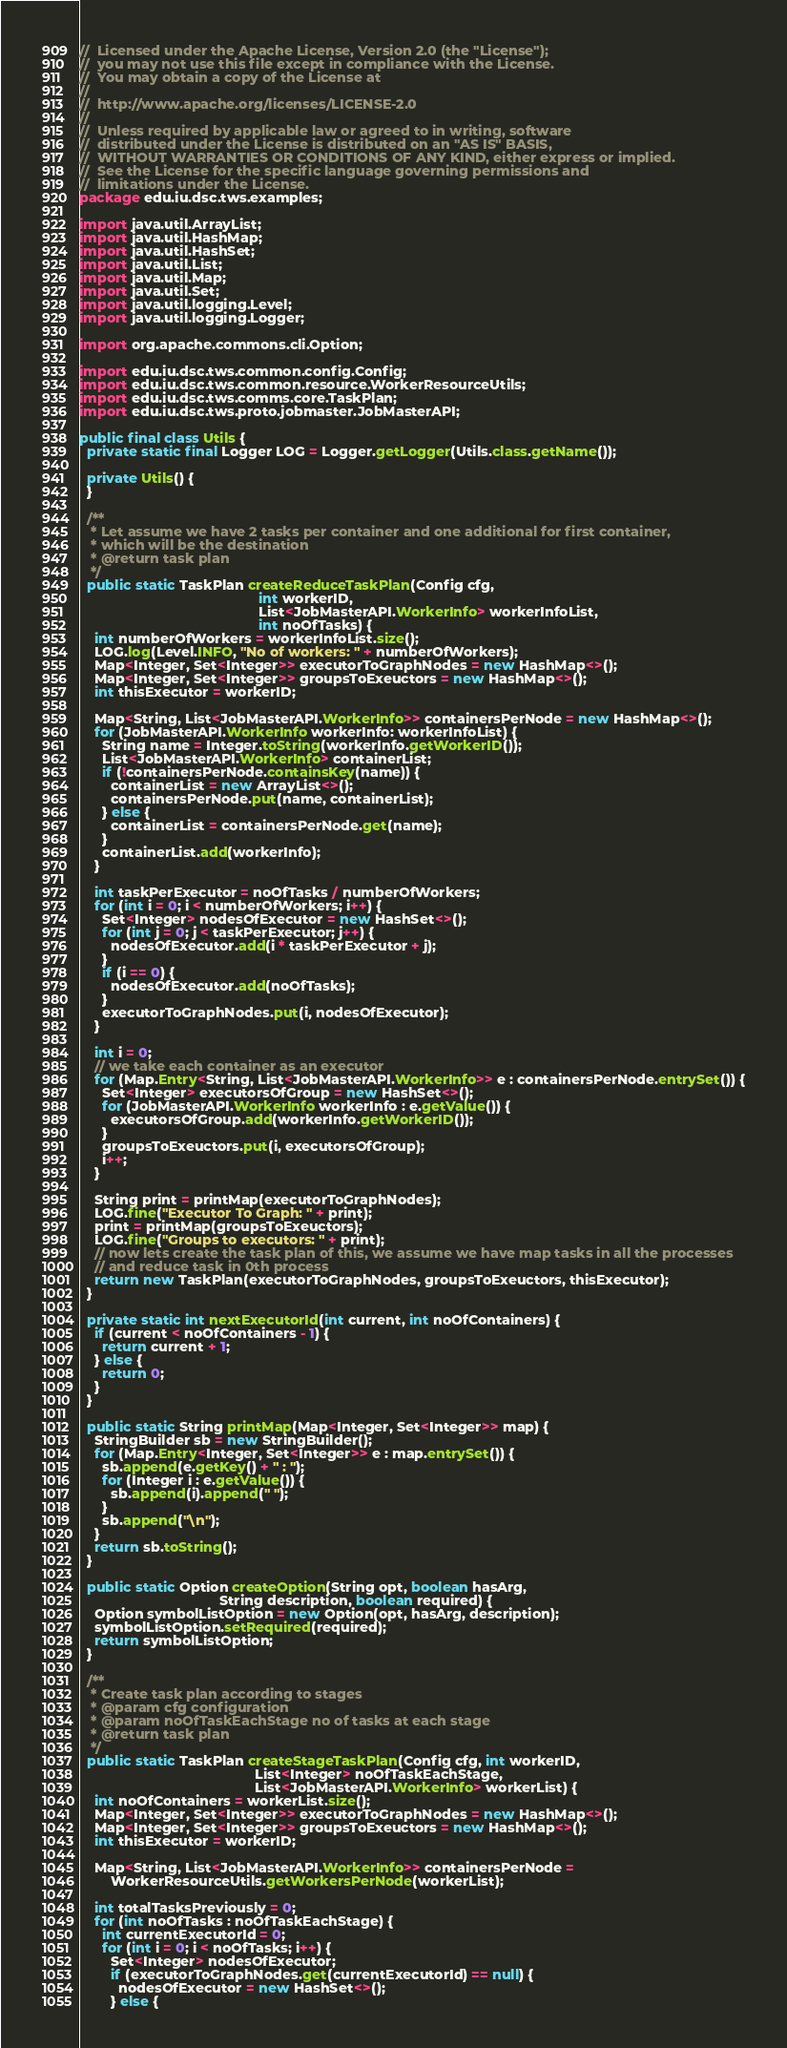<code> <loc_0><loc_0><loc_500><loc_500><_Java_>//  Licensed under the Apache License, Version 2.0 (the "License");
//  you may not use this file except in compliance with the License.
//  You may obtain a copy of the License at
//
//  http://www.apache.org/licenses/LICENSE-2.0
//
//  Unless required by applicable law or agreed to in writing, software
//  distributed under the License is distributed on an "AS IS" BASIS,
//  WITHOUT WARRANTIES OR CONDITIONS OF ANY KIND, either express or implied.
//  See the License for the specific language governing permissions and
//  limitations under the License.
package edu.iu.dsc.tws.examples;

import java.util.ArrayList;
import java.util.HashMap;
import java.util.HashSet;
import java.util.List;
import java.util.Map;
import java.util.Set;
import java.util.logging.Level;
import java.util.logging.Logger;

import org.apache.commons.cli.Option;

import edu.iu.dsc.tws.common.config.Config;
import edu.iu.dsc.tws.common.resource.WorkerResourceUtils;
import edu.iu.dsc.tws.comms.core.TaskPlan;
import edu.iu.dsc.tws.proto.jobmaster.JobMasterAPI;

public final class Utils {
  private static final Logger LOG = Logger.getLogger(Utils.class.getName());

  private Utils() {
  }

  /**
   * Let assume we have 2 tasks per container and one additional for first container,
   * which will be the destination
   * @return task plan
   */
  public static TaskPlan createReduceTaskPlan(Config cfg,
                                              int workerID,
                                              List<JobMasterAPI.WorkerInfo> workerInfoList,
                                              int noOfTasks) {
    int numberOfWorkers = workerInfoList.size();
    LOG.log(Level.INFO, "No of workers: " + numberOfWorkers);
    Map<Integer, Set<Integer>> executorToGraphNodes = new HashMap<>();
    Map<Integer, Set<Integer>> groupsToExeuctors = new HashMap<>();
    int thisExecutor = workerID;

    Map<String, List<JobMasterAPI.WorkerInfo>> containersPerNode = new HashMap<>();
    for (JobMasterAPI.WorkerInfo workerInfo: workerInfoList) {
      String name = Integer.toString(workerInfo.getWorkerID());
      List<JobMasterAPI.WorkerInfo> containerList;
      if (!containersPerNode.containsKey(name)) {
        containerList = new ArrayList<>();
        containersPerNode.put(name, containerList);
      } else {
        containerList = containersPerNode.get(name);
      }
      containerList.add(workerInfo);
    }

    int taskPerExecutor = noOfTasks / numberOfWorkers;
    for (int i = 0; i < numberOfWorkers; i++) {
      Set<Integer> nodesOfExecutor = new HashSet<>();
      for (int j = 0; j < taskPerExecutor; j++) {
        nodesOfExecutor.add(i * taskPerExecutor + j);
      }
      if (i == 0) {
        nodesOfExecutor.add(noOfTasks);
      }
      executorToGraphNodes.put(i, nodesOfExecutor);
    }

    int i = 0;
    // we take each container as an executor
    for (Map.Entry<String, List<JobMasterAPI.WorkerInfo>> e : containersPerNode.entrySet()) {
      Set<Integer> executorsOfGroup = new HashSet<>();
      for (JobMasterAPI.WorkerInfo workerInfo : e.getValue()) {
        executorsOfGroup.add(workerInfo.getWorkerID());
      }
      groupsToExeuctors.put(i, executorsOfGroup);
      i++;
    }

    String print = printMap(executorToGraphNodes);
    LOG.fine("Executor To Graph: " + print);
    print = printMap(groupsToExeuctors);
    LOG.fine("Groups to executors: " + print);
    // now lets create the task plan of this, we assume we have map tasks in all the processes
    // and reduce task in 0th process
    return new TaskPlan(executorToGraphNodes, groupsToExeuctors, thisExecutor);
  }

  private static int nextExecutorId(int current, int noOfContainers) {
    if (current < noOfContainers - 1) {
      return current + 1;
    } else {
      return 0;
    }
  }

  public static String printMap(Map<Integer, Set<Integer>> map) {
    StringBuilder sb = new StringBuilder();
    for (Map.Entry<Integer, Set<Integer>> e : map.entrySet()) {
      sb.append(e.getKey() + " : ");
      for (Integer i : e.getValue()) {
        sb.append(i).append(" ");
      }
      sb.append("\n");
    }
    return sb.toString();
  }

  public static Option createOption(String opt, boolean hasArg,
                                    String description, boolean required) {
    Option symbolListOption = new Option(opt, hasArg, description);
    symbolListOption.setRequired(required);
    return symbolListOption;
  }

  /**
   * Create task plan according to stages
   * @param cfg configuration
   * @param noOfTaskEachStage no of tasks at each stage
   * @return task plan
   */
  public static TaskPlan createStageTaskPlan(Config cfg, int workerID,
                                             List<Integer> noOfTaskEachStage,
                                             List<JobMasterAPI.WorkerInfo> workerList) {
    int noOfContainers = workerList.size();
    Map<Integer, Set<Integer>> executorToGraphNodes = new HashMap<>();
    Map<Integer, Set<Integer>> groupsToExeuctors = new HashMap<>();
    int thisExecutor = workerID;

    Map<String, List<JobMasterAPI.WorkerInfo>> containersPerNode =
        WorkerResourceUtils.getWorkersPerNode(workerList);

    int totalTasksPreviously = 0;
    for (int noOfTasks : noOfTaskEachStage) {
      int currentExecutorId = 0;
      for (int i = 0; i < noOfTasks; i++) {
        Set<Integer> nodesOfExecutor;
        if (executorToGraphNodes.get(currentExecutorId) == null) {
          nodesOfExecutor = new HashSet<>();
        } else {</code> 